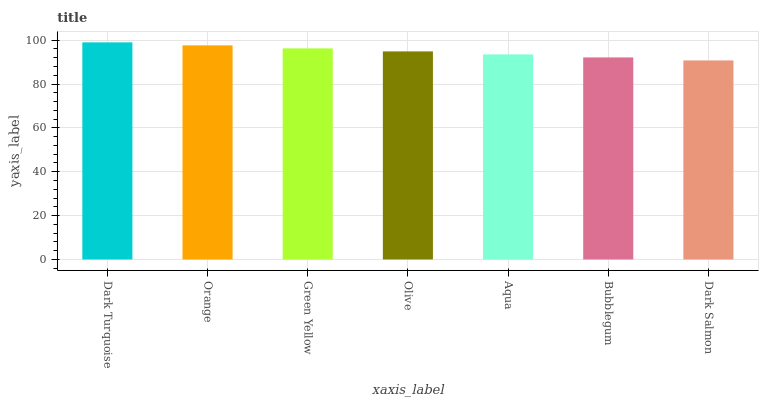Is Dark Salmon the minimum?
Answer yes or no. Yes. Is Dark Turquoise the maximum?
Answer yes or no. Yes. Is Orange the minimum?
Answer yes or no. No. Is Orange the maximum?
Answer yes or no. No. Is Dark Turquoise greater than Orange?
Answer yes or no. Yes. Is Orange less than Dark Turquoise?
Answer yes or no. Yes. Is Orange greater than Dark Turquoise?
Answer yes or no. No. Is Dark Turquoise less than Orange?
Answer yes or no. No. Is Olive the high median?
Answer yes or no. Yes. Is Olive the low median?
Answer yes or no. Yes. Is Aqua the high median?
Answer yes or no. No. Is Aqua the low median?
Answer yes or no. No. 